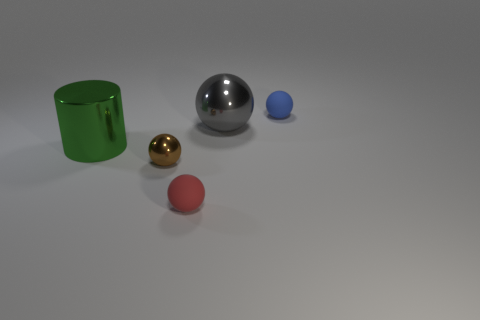Add 4 things. How many objects exist? 9 Subtract all balls. How many objects are left? 1 Add 2 big gray balls. How many big gray balls exist? 3 Subtract 1 green cylinders. How many objects are left? 4 Subtract all tiny blue rubber things. Subtract all cylinders. How many objects are left? 3 Add 2 large green metal things. How many large green metal things are left? 3 